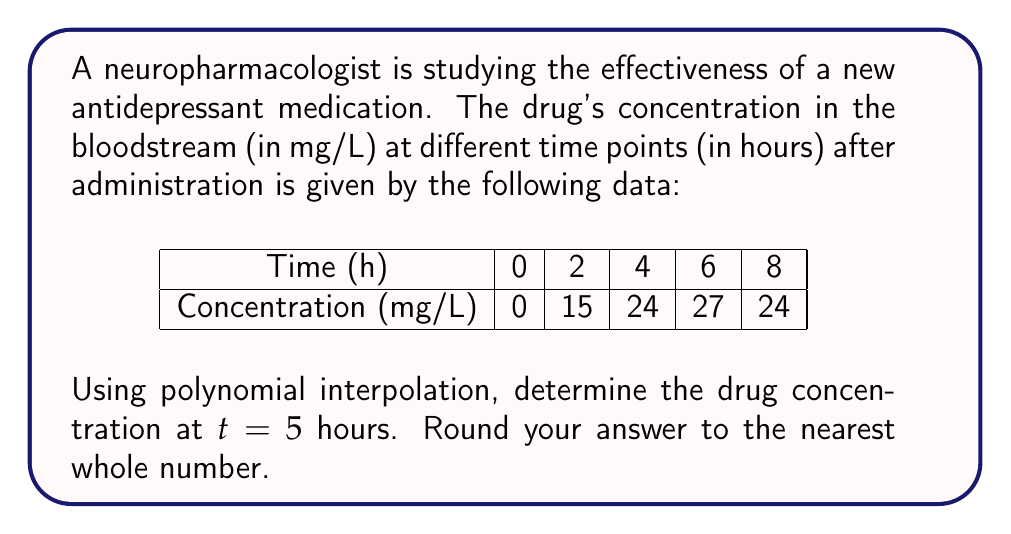Provide a solution to this math problem. To solve this problem, we'll use Lagrange polynomial interpolation:

1) The Lagrange interpolation polynomial is given by:
   $$P(x) = \sum_{i=0}^n y_i \cdot L_i(x)$$
   where $L_i(x) = \prod_{j\neq i} \frac{x-x_j}{x_i-x_j}$

2) For our data points:
   $(x_0,y_0)=(0,0)$, $(x_1,y_1)=(2,15)$, $(x_2,y_2)=(4,24)$, $(x_3,y_3)=(6,27)$, $(x_4,y_4)=(8,24)$

3) Calculate each $L_i(5)$:

   $L_0(5) = \frac{(5-2)(5-4)(5-6)(5-8)}{(0-2)(0-4)(0-6)(0-8)} = \frac{3 \cdot 1 \cdot (-1) \cdot (-3)}{-2 \cdot (-4) \cdot (-6) \cdot (-8)} = -\frac{9}{192}$

   $L_1(5) = \frac{(5-0)(5-4)(5-6)(5-8)}{(2-0)(2-4)(2-6)(2-8)} = \frac{5 \cdot 1 \cdot (-1) \cdot (-3)}{2 \cdot (-2) \cdot (-4) \cdot (-6)} = \frac{15}{48}$

   $L_2(5) = \frac{(5-0)(5-2)(5-6)(5-8)}{(4-0)(4-2)(4-6)(4-8)} = \frac{5 \cdot 3 \cdot (-1) \cdot (-3)}{4 \cdot 2 \cdot (-2) \cdot (-4)} = \frac{45}{64}$

   $L_3(5) = \frac{(5-0)(5-2)(5-4)(5-8)}{(6-0)(6-2)(6-4)(6-8)} = \frac{5 \cdot 3 \cdot 1 \cdot (-3)}{6 \cdot 4 \cdot 2 \cdot (-2)} = -\frac{15}{16}$

   $L_4(5) = \frac{(5-0)(5-2)(5-4)(5-6)}{(8-0)(8-2)(8-4)(8-6)} = \frac{5 \cdot 3 \cdot 1 \cdot (-1)}{8 \cdot 6 \cdot 4 \cdot 2} = -\frac{15}{192}$

4) Now, calculate $P(5)$:
   $$P(5) = 0 \cdot (-\frac{9}{192}) + 15 \cdot (\frac{15}{48}) + 24 \cdot (\frac{45}{64}) + 27 \cdot (-\frac{15}{16}) + 24 \cdot (-\frac{15}{192})$$

5) Simplify:
   $$P(5) = 0 + 4.6875 + 16.875 - 25.3125 - 1.875 = -5.625$$

6) Rounding to the nearest whole number: -6
Answer: -6 mg/L 